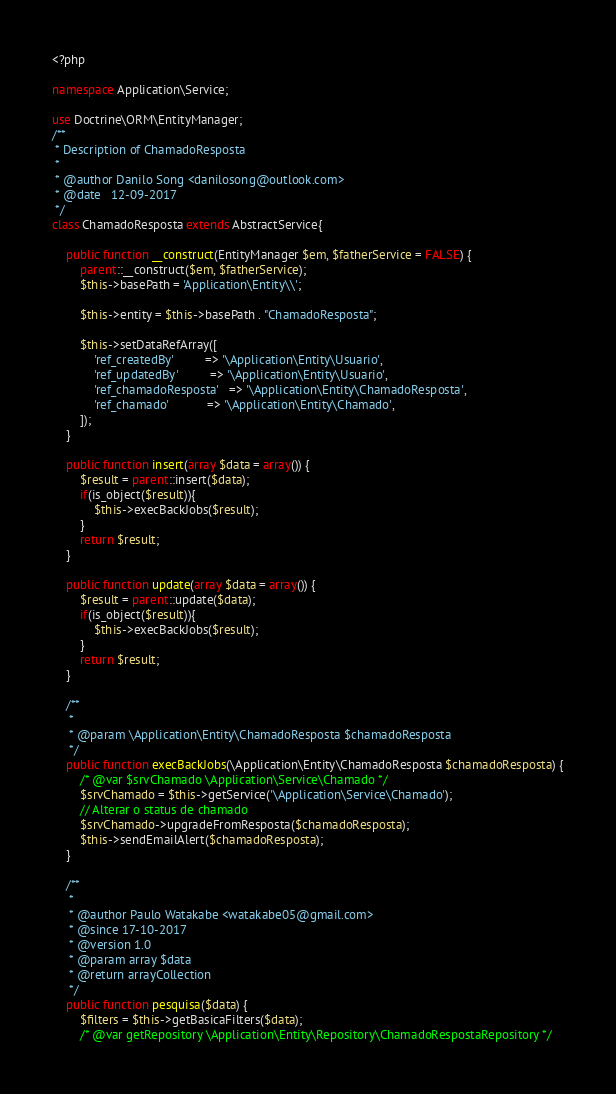<code> <loc_0><loc_0><loc_500><loc_500><_PHP_><?php

namespace Application\Service;

use Doctrine\ORM\EntityManager;
/**
 * Description of ChamadoResposta
 *
 * @author Danilo Song <danilosong@outlook.com>
 * @date   12-09-2017
 */
class ChamadoResposta extends AbstractService{       
    
    public function __construct(EntityManager $em, $fatherService = FALSE) {
        parent::__construct($em, $fatherService);
        $this->basePath = 'Application\Entity\\';

        $this->entity = $this->basePath . "ChamadoResposta";

        $this->setDataRefArray([
            'ref_createdBy'         => '\Application\Entity\Usuario',
            'ref_updatedBy'         => '\Application\Entity\Usuario',
            'ref_chamadoResposta'   => '\Application\Entity\ChamadoResposta',
            'ref_chamado'           => '\Application\Entity\Chamado',
        ]);
    }
    
    public function insert(array $data = array()) {
        $result = parent::insert($data);
        if(is_object($result)){
            $this->execBackJobs($result);
        }
        return $result;
    }
    
    public function update(array $data = array()) {
        $result = parent::update($data);
        if(is_object($result)){
            $this->execBackJobs($result);
        }
        return $result;
    }
    
    /**
     * 
     * @param \Application\Entity\ChamadoResposta $chamadoResposta
     */
    public function execBackJobs(\Application\Entity\ChamadoResposta $chamadoResposta) {
        /* @var $srvChamado \Application\Service\Chamado */
        $srvChamado = $this->getService('\Application\Service\Chamado');
        // Alterar o status de chamado
        $srvChamado->upgradeFromResposta($chamadoResposta);    
        $this->sendEmailAlert($chamadoResposta);
    }
    
    /**
     * 
     * @author Paulo Watakabe <watakabe05@gmail.com>
     * @since 17-10-2017
     * @version 1.0
     * @param array $data
     * @return arrayCollection
     */
    public function pesquisa($data) {
        $filters = $this->getBasicaFilters($data);
        /* @var getRepository \Application\Entity\Repository\ChamadoRespostaRepository */</code> 